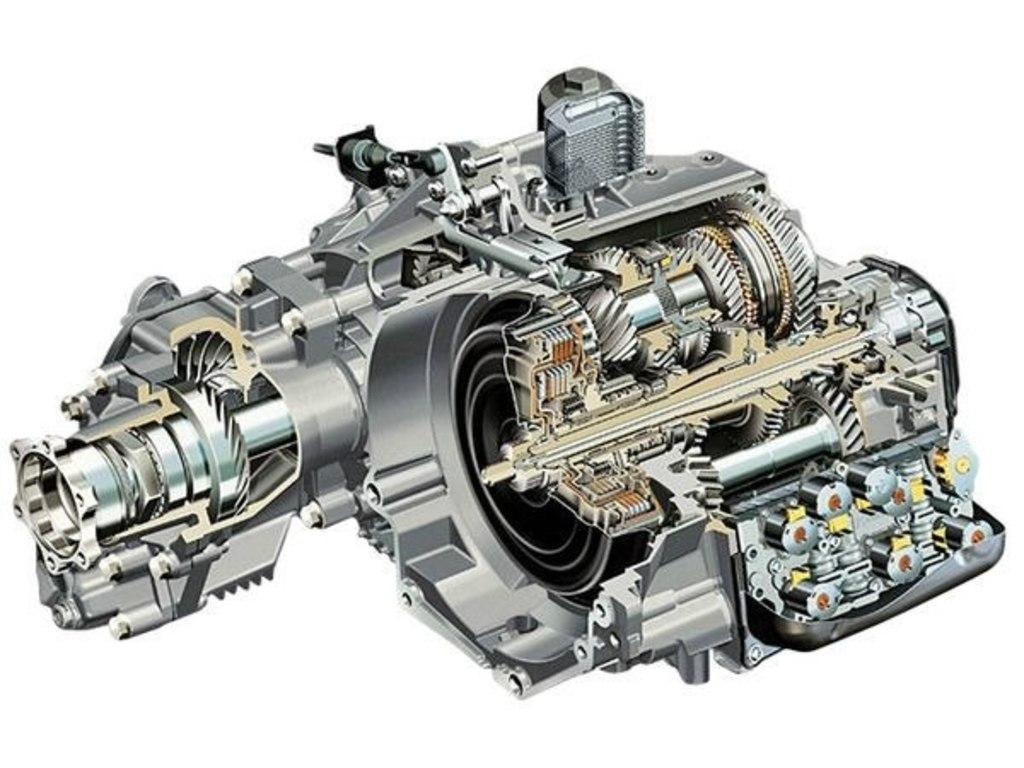What is the main subject of the picture? The main subject of the picture is an engine. What color is the background of the image? The background of the image is white. How many branches can be seen growing from the engine in the image? There are no branches present in the image, as it features an engine and a white background. What type of chess pieces are visible on the engine in the image? There are no chess pieces present in the image; it only shows an engine and a white background. 